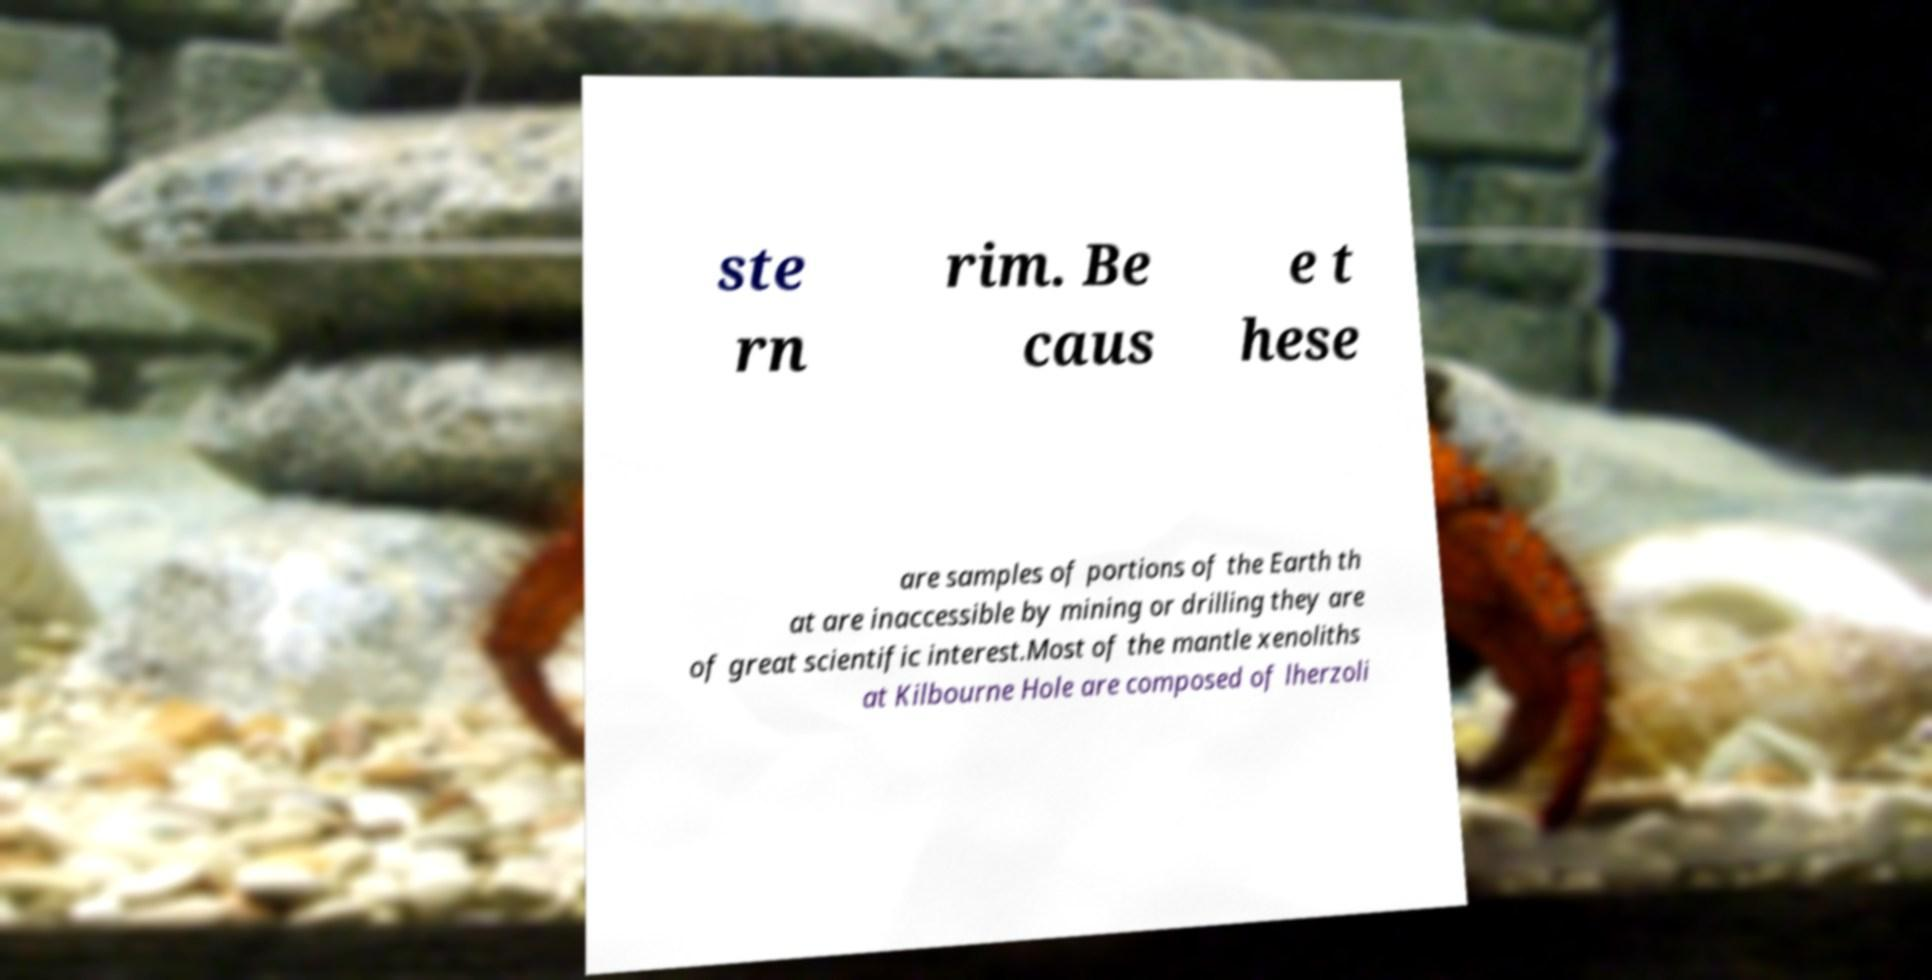Please identify and transcribe the text found in this image. ste rn rim. Be caus e t hese are samples of portions of the Earth th at are inaccessible by mining or drilling they are of great scientific interest.Most of the mantle xenoliths at Kilbourne Hole are composed of lherzoli 